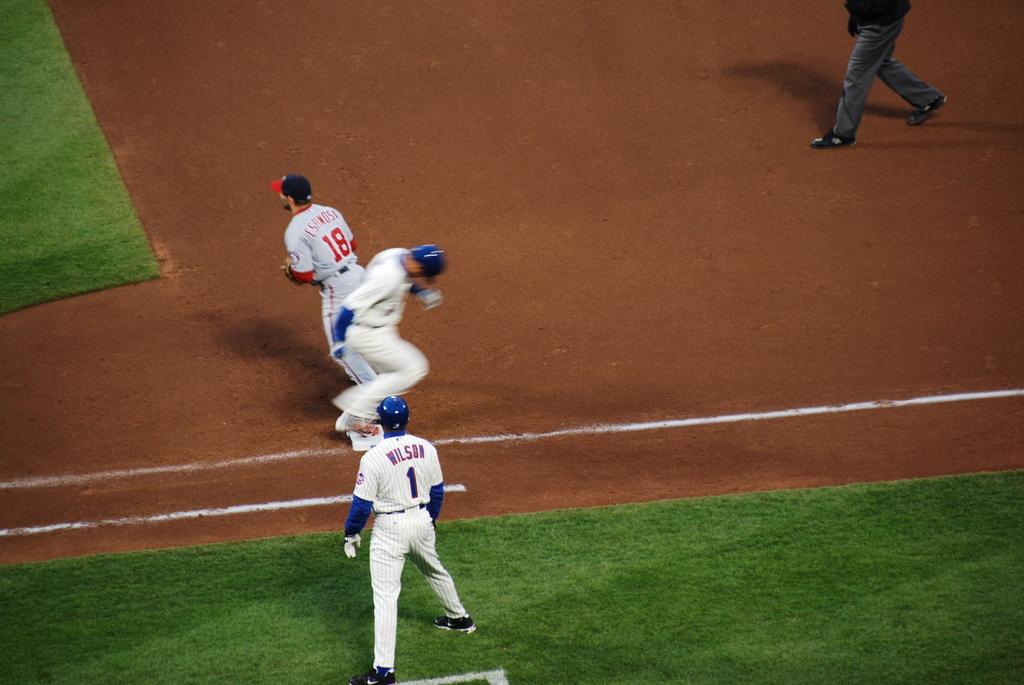What is the player's name?
Offer a terse response. Wilson. What is the number of the base coach?
Your response must be concise. 1. 